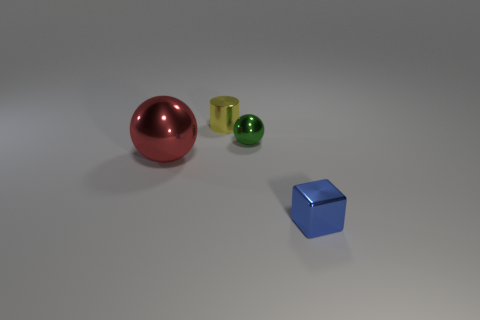Add 1 small yellow metallic things. How many objects exist? 5 Subtract all blocks. How many objects are left? 3 Add 2 tiny yellow objects. How many tiny yellow objects are left? 3 Add 2 yellow metal objects. How many yellow metal objects exist? 3 Subtract 0 gray blocks. How many objects are left? 4 Subtract all small metallic cubes. Subtract all blue objects. How many objects are left? 2 